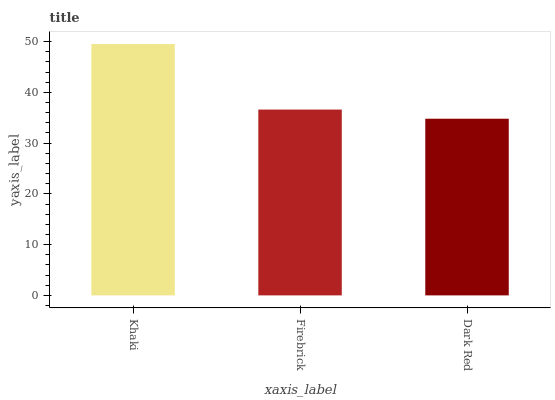Is Dark Red the minimum?
Answer yes or no. Yes. Is Khaki the maximum?
Answer yes or no. Yes. Is Firebrick the minimum?
Answer yes or no. No. Is Firebrick the maximum?
Answer yes or no. No. Is Khaki greater than Firebrick?
Answer yes or no. Yes. Is Firebrick less than Khaki?
Answer yes or no. Yes. Is Firebrick greater than Khaki?
Answer yes or no. No. Is Khaki less than Firebrick?
Answer yes or no. No. Is Firebrick the high median?
Answer yes or no. Yes. Is Firebrick the low median?
Answer yes or no. Yes. Is Dark Red the high median?
Answer yes or no. No. Is Khaki the low median?
Answer yes or no. No. 